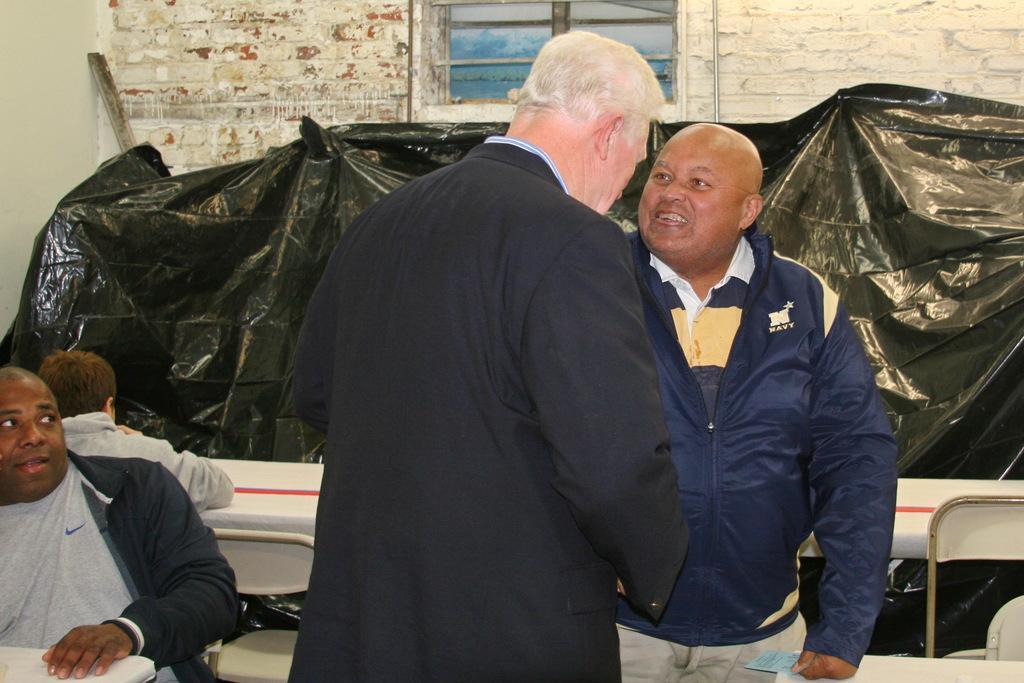In one or two sentences, can you explain what this image depicts? In this image we can see two people standing. On the left there are people sitting there are tables and chairs. We can see a cover. In the background there is a wall and we can see a window. 